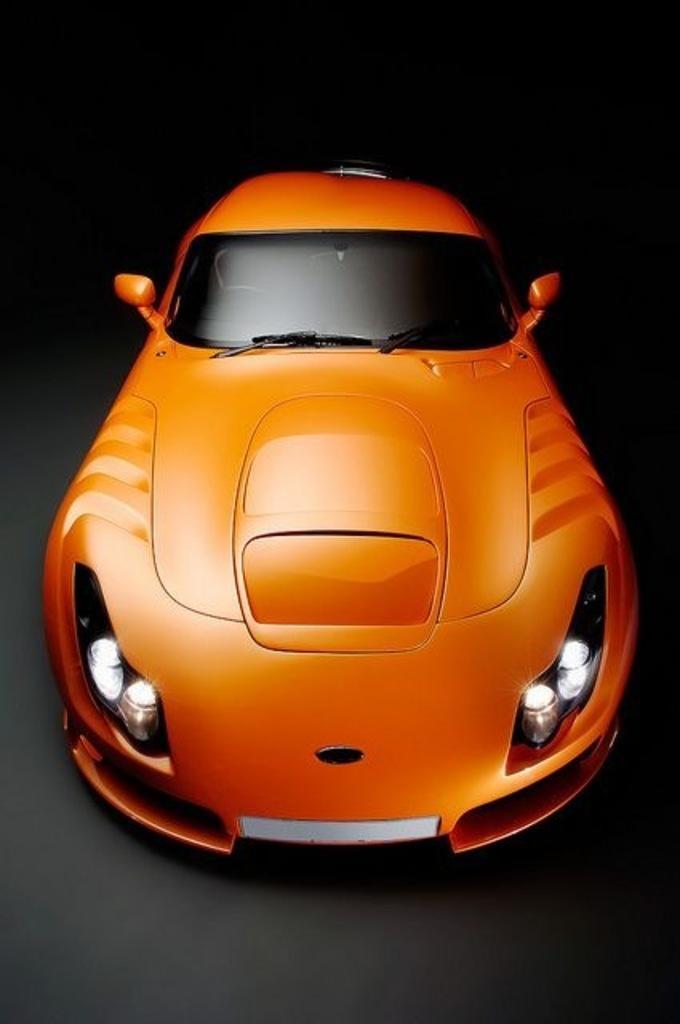Describe this image in one or two sentences. In the center of the image, we can see a car. 